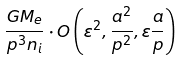<formula> <loc_0><loc_0><loc_500><loc_500>\frac { G M _ { e } } { p ^ { 3 } n _ { i } } \cdot O \left ( \varepsilon ^ { 2 } , \frac { a ^ { 2 } } { p ^ { 2 } } , \varepsilon \frac { a } { p } \right )</formula> 